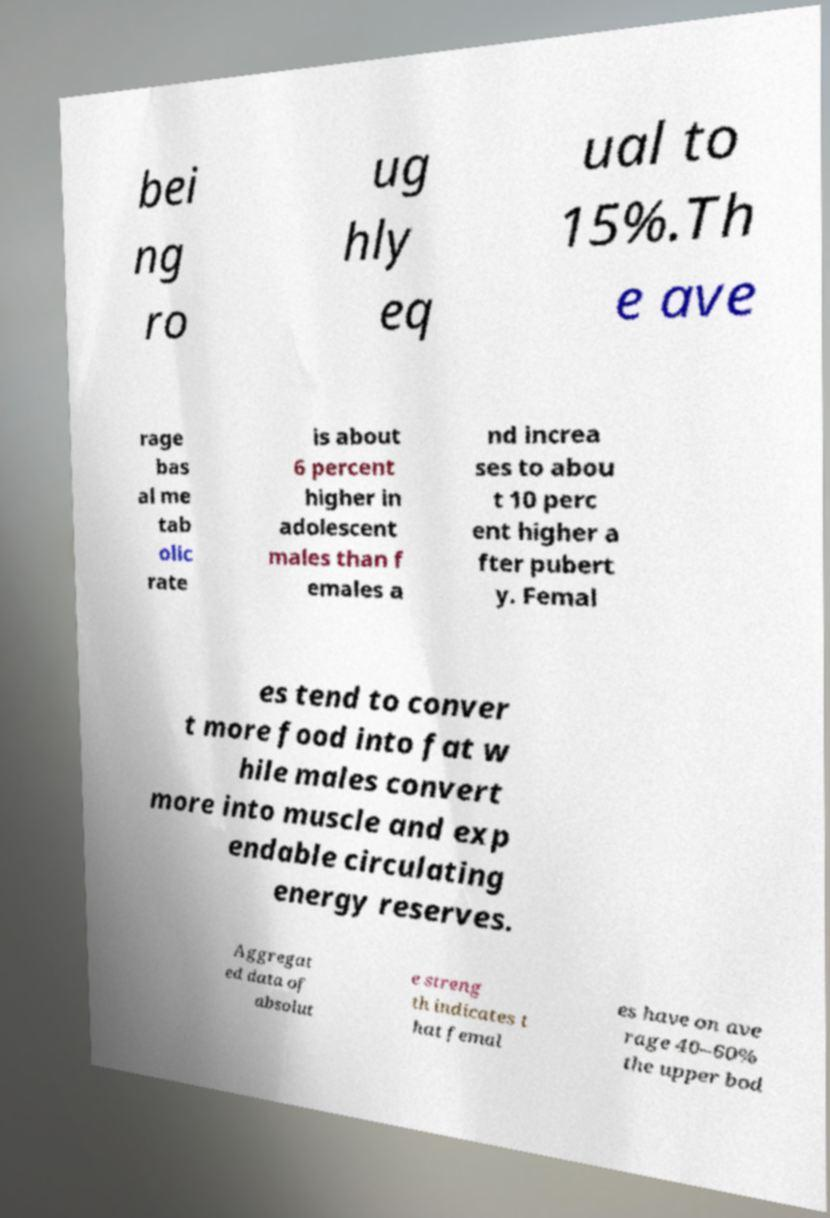Please read and relay the text visible in this image. What does it say? bei ng ro ug hly eq ual to 15%.Th e ave rage bas al me tab olic rate is about 6 percent higher in adolescent males than f emales a nd increa ses to abou t 10 perc ent higher a fter pubert y. Femal es tend to conver t more food into fat w hile males convert more into muscle and exp endable circulating energy reserves. Aggregat ed data of absolut e streng th indicates t hat femal es have on ave rage 40–60% the upper bod 